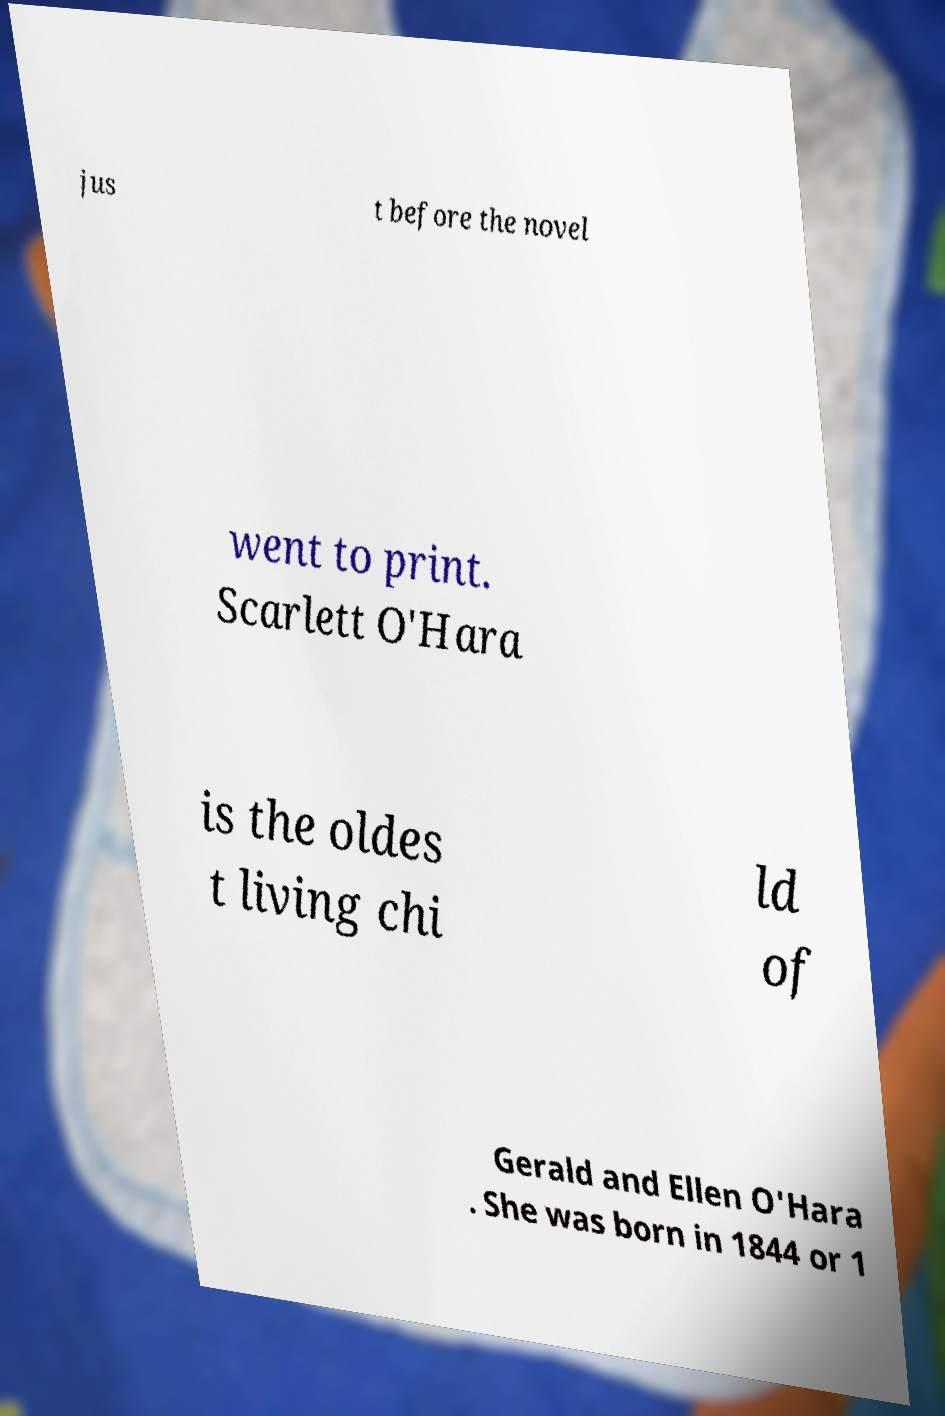There's text embedded in this image that I need extracted. Can you transcribe it verbatim? jus t before the novel went to print. Scarlett O'Hara is the oldes t living chi ld of Gerald and Ellen O'Hara . She was born in 1844 or 1 